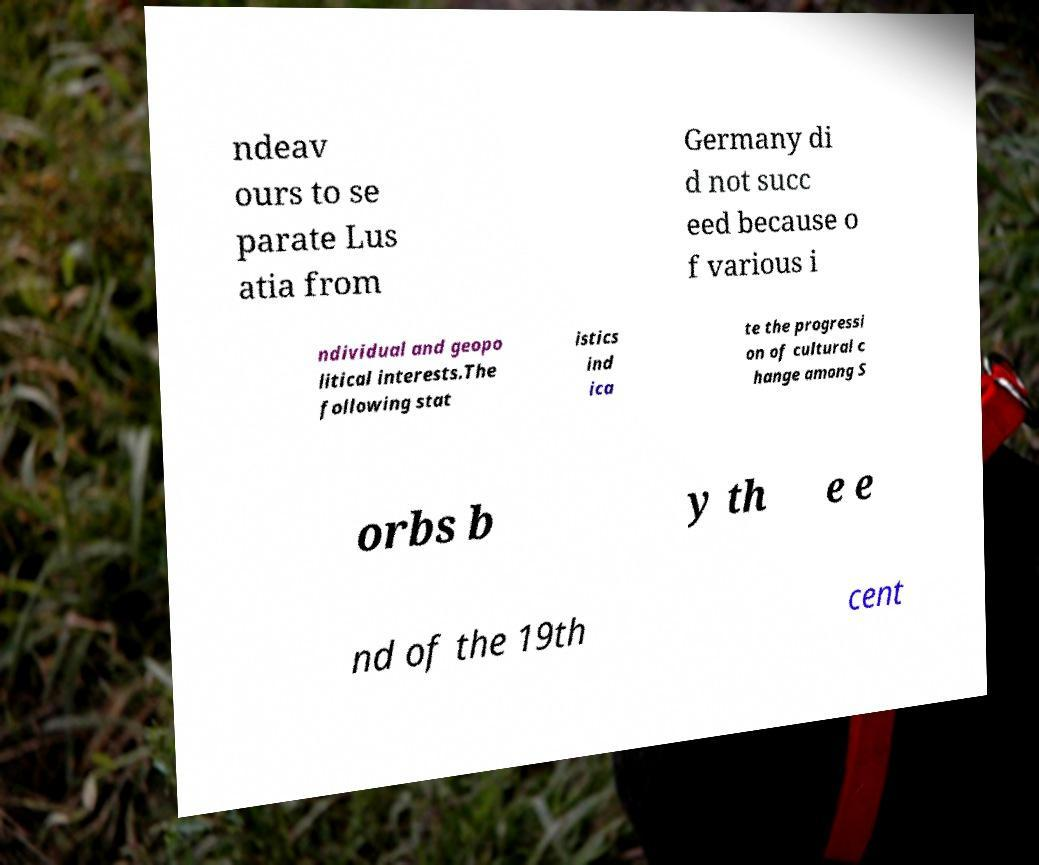There's text embedded in this image that I need extracted. Can you transcribe it verbatim? ndeav ours to se parate Lus atia from Germany di d not succ eed because o f various i ndividual and geopo litical interests.The following stat istics ind ica te the progressi on of cultural c hange among S orbs b y th e e nd of the 19th cent 